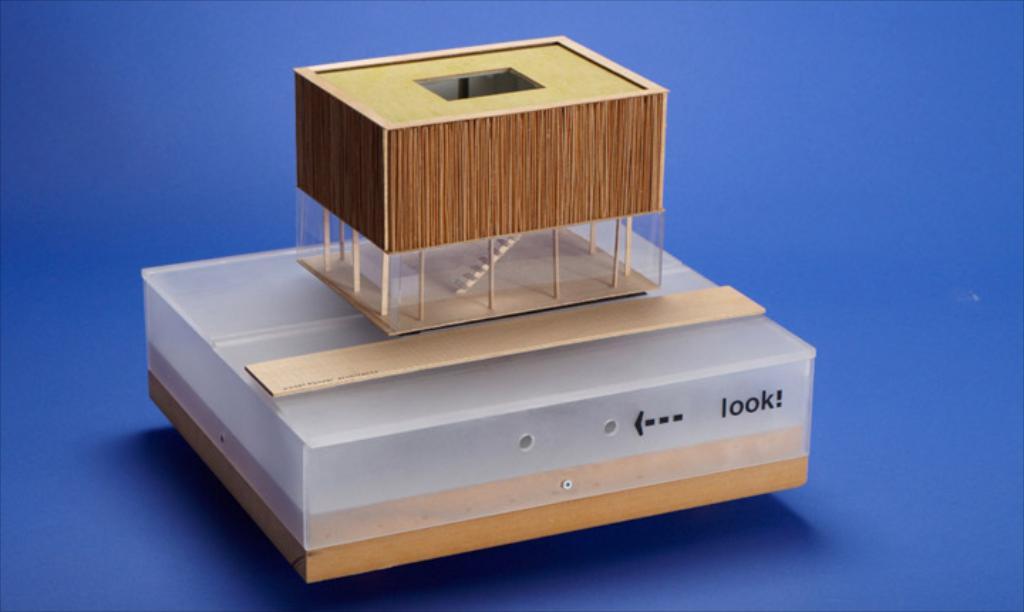What does it say in black letters on the model?
Provide a short and direct response. Look!. 